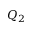Convert formula to latex. <formula><loc_0><loc_0><loc_500><loc_500>Q _ { 2 }</formula> 